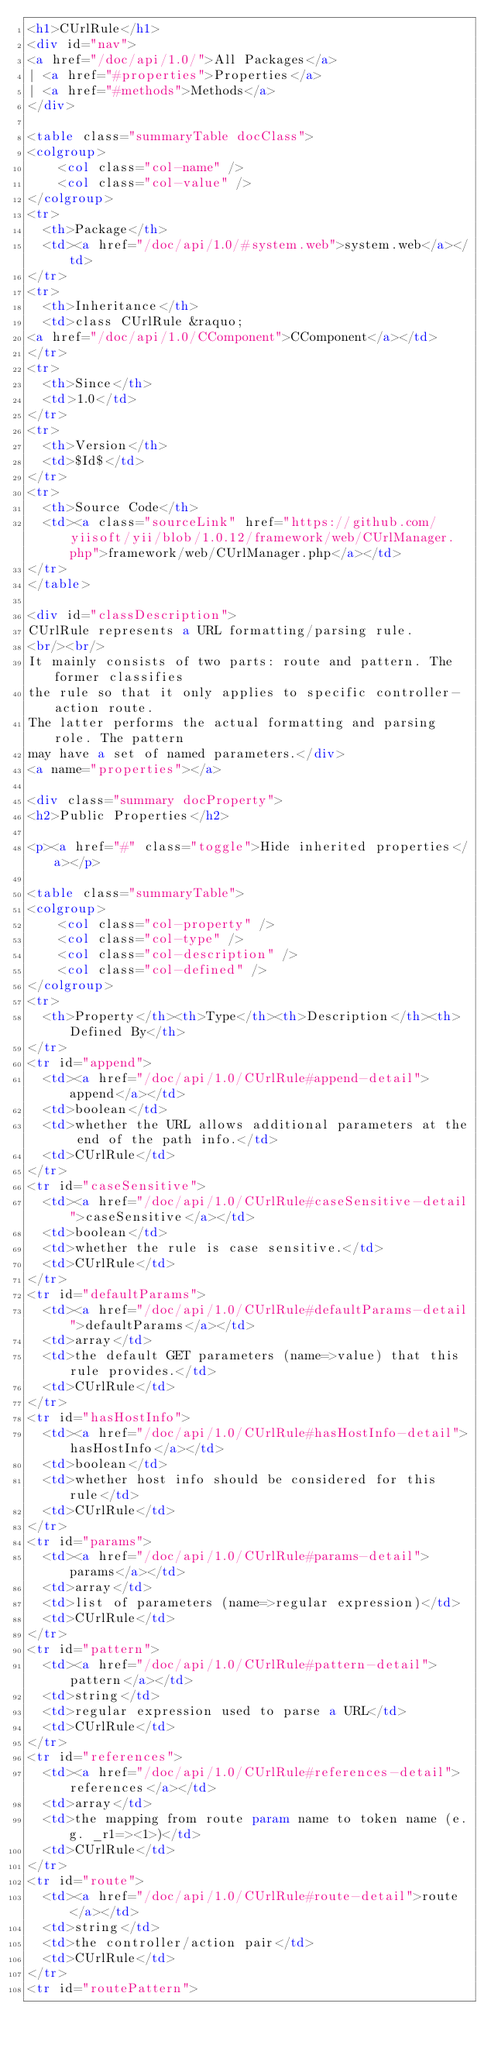Convert code to text. <code><loc_0><loc_0><loc_500><loc_500><_HTML_><h1>CUrlRule</h1>
<div id="nav">
<a href="/doc/api/1.0/">All Packages</a>
| <a href="#properties">Properties</a>
| <a href="#methods">Methods</a>
</div>

<table class="summaryTable docClass">
<colgroup>
	<col class="col-name" />
	<col class="col-value" />
</colgroup>
<tr>
  <th>Package</th>
  <td><a href="/doc/api/1.0/#system.web">system.web</a></td>
</tr>
<tr>
  <th>Inheritance</th>
  <td>class CUrlRule &raquo;
<a href="/doc/api/1.0/CComponent">CComponent</a></td>
</tr>
<tr>
  <th>Since</th>
  <td>1.0</td>
</tr>
<tr>
  <th>Version</th>
  <td>$Id$</td>
</tr>
<tr>
  <th>Source Code</th>
  <td><a class="sourceLink" href="https://github.com/yiisoft/yii/blob/1.0.12/framework/web/CUrlManager.php">framework/web/CUrlManager.php</a></td>
</tr>
</table>

<div id="classDescription">
CUrlRule represents a URL formatting/parsing rule.
<br/><br/>
It mainly consists of two parts: route and pattern. The former classifies
the rule so that it only applies to specific controller-action route.
The latter performs the actual formatting and parsing role. The pattern
may have a set of named parameters.</div>
<a name="properties"></a>

<div class="summary docProperty">
<h2>Public Properties</h2>

<p><a href="#" class="toggle">Hide inherited properties</a></p>

<table class="summaryTable">
<colgroup>
	<col class="col-property" />
	<col class="col-type" />
	<col class="col-description" />
	<col class="col-defined" />
</colgroup>
<tr>
  <th>Property</th><th>Type</th><th>Description</th><th>Defined By</th>
</tr>
<tr id="append">
  <td><a href="/doc/api/1.0/CUrlRule#append-detail">append</a></td>
  <td>boolean</td>
  <td>whether the URL allows additional parameters at the end of the path info.</td>
  <td>CUrlRule</td>
</tr>
<tr id="caseSensitive">
  <td><a href="/doc/api/1.0/CUrlRule#caseSensitive-detail">caseSensitive</a></td>
  <td>boolean</td>
  <td>whether the rule is case sensitive.</td>
  <td>CUrlRule</td>
</tr>
<tr id="defaultParams">
  <td><a href="/doc/api/1.0/CUrlRule#defaultParams-detail">defaultParams</a></td>
  <td>array</td>
  <td>the default GET parameters (name=>value) that this rule provides.</td>
  <td>CUrlRule</td>
</tr>
<tr id="hasHostInfo">
  <td><a href="/doc/api/1.0/CUrlRule#hasHostInfo-detail">hasHostInfo</a></td>
  <td>boolean</td>
  <td>whether host info should be considered for this rule</td>
  <td>CUrlRule</td>
</tr>
<tr id="params">
  <td><a href="/doc/api/1.0/CUrlRule#params-detail">params</a></td>
  <td>array</td>
  <td>list of parameters (name=>regular expression)</td>
  <td>CUrlRule</td>
</tr>
<tr id="pattern">
  <td><a href="/doc/api/1.0/CUrlRule#pattern-detail">pattern</a></td>
  <td>string</td>
  <td>regular expression used to parse a URL</td>
  <td>CUrlRule</td>
</tr>
<tr id="references">
  <td><a href="/doc/api/1.0/CUrlRule#references-detail">references</a></td>
  <td>array</td>
  <td>the mapping from route param name to token name (e.g. _r1=><1>)</td>
  <td>CUrlRule</td>
</tr>
<tr id="route">
  <td><a href="/doc/api/1.0/CUrlRule#route-detail">route</a></td>
  <td>string</td>
  <td>the controller/action pair</td>
  <td>CUrlRule</td>
</tr>
<tr id="routePattern"></code> 